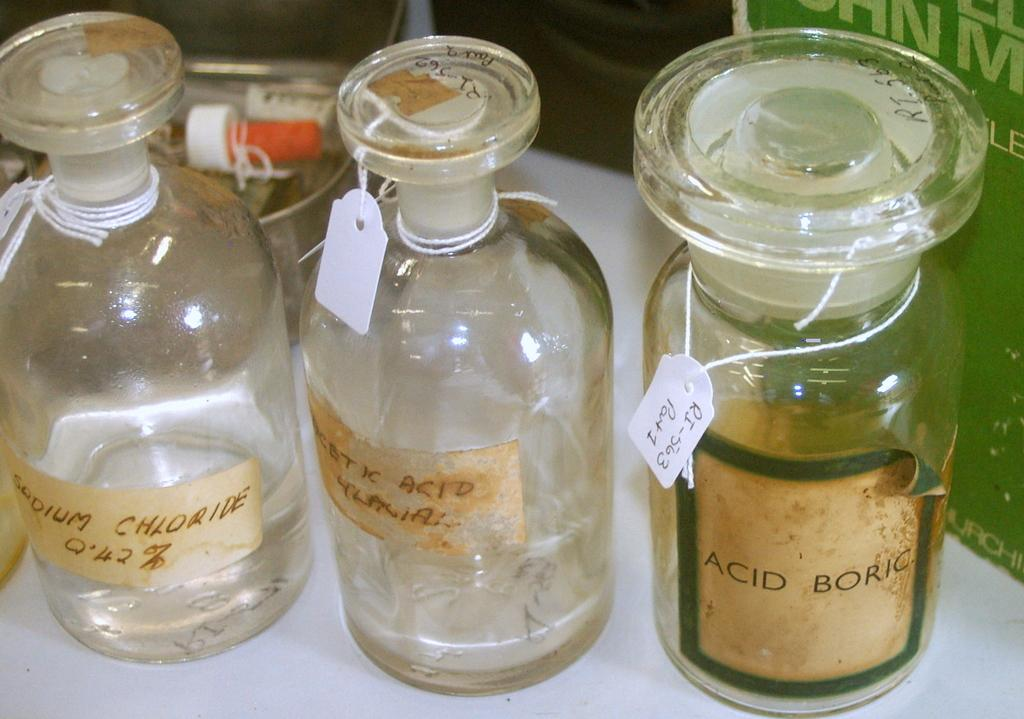What objects are on the table in the image? There are bottles on the table. What type of income can be seen in the image? There is no income present in the image; it only features bottles on a table. What riddle is the image trying to solve? The image is not trying to solve a riddle; it is a simple depiction of bottles on a table. 